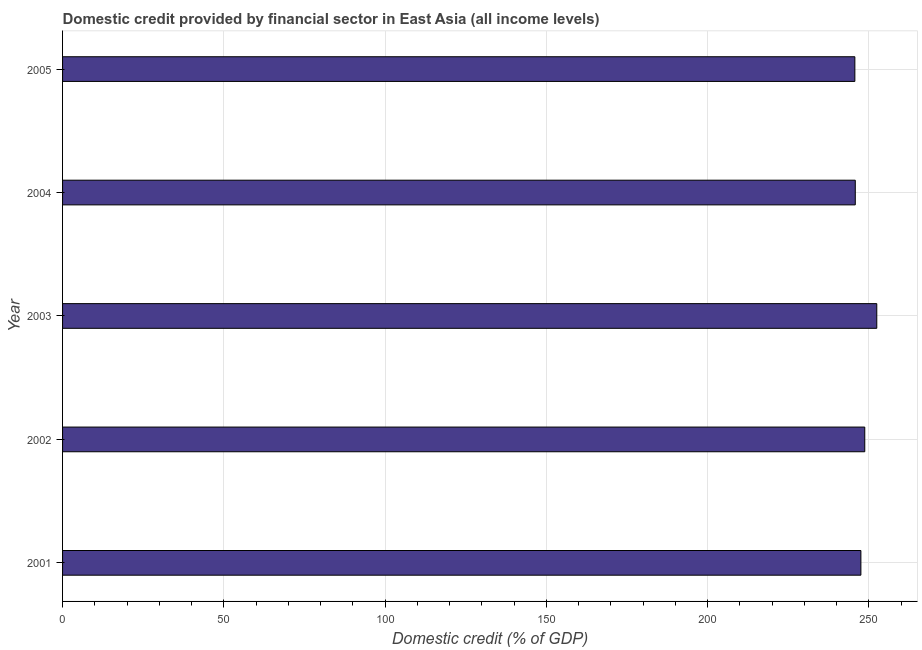What is the title of the graph?
Make the answer very short. Domestic credit provided by financial sector in East Asia (all income levels). What is the label or title of the X-axis?
Your response must be concise. Domestic credit (% of GDP). What is the label or title of the Y-axis?
Offer a very short reply. Year. What is the domestic credit provided by financial sector in 2004?
Ensure brevity in your answer.  245.82. Across all years, what is the maximum domestic credit provided by financial sector?
Offer a terse response. 252.49. Across all years, what is the minimum domestic credit provided by financial sector?
Ensure brevity in your answer.  245.69. In which year was the domestic credit provided by financial sector maximum?
Your answer should be very brief. 2003. In which year was the domestic credit provided by financial sector minimum?
Provide a succinct answer. 2005. What is the sum of the domestic credit provided by financial sector?
Make the answer very short. 1240.33. What is the difference between the domestic credit provided by financial sector in 2004 and 2005?
Make the answer very short. 0.13. What is the average domestic credit provided by financial sector per year?
Provide a succinct answer. 248.07. What is the median domestic credit provided by financial sector?
Give a very brief answer. 247.56. In how many years, is the domestic credit provided by financial sector greater than 110 %?
Offer a terse response. 5. Do a majority of the years between 2001 and 2005 (inclusive) have domestic credit provided by financial sector greater than 240 %?
Offer a very short reply. Yes. What is the ratio of the domestic credit provided by financial sector in 2001 to that in 2002?
Your answer should be very brief. 0.99. What is the difference between the highest and the second highest domestic credit provided by financial sector?
Ensure brevity in your answer.  3.73. Are all the bars in the graph horizontal?
Your answer should be very brief. Yes. What is the difference between two consecutive major ticks on the X-axis?
Give a very brief answer. 50. Are the values on the major ticks of X-axis written in scientific E-notation?
Provide a succinct answer. No. What is the Domestic credit (% of GDP) of 2001?
Offer a terse response. 247.56. What is the Domestic credit (% of GDP) of 2002?
Give a very brief answer. 248.76. What is the Domestic credit (% of GDP) of 2003?
Your response must be concise. 252.49. What is the Domestic credit (% of GDP) in 2004?
Give a very brief answer. 245.82. What is the Domestic credit (% of GDP) of 2005?
Provide a succinct answer. 245.69. What is the difference between the Domestic credit (% of GDP) in 2001 and 2002?
Ensure brevity in your answer.  -1.21. What is the difference between the Domestic credit (% of GDP) in 2001 and 2003?
Keep it short and to the point. -4.93. What is the difference between the Domestic credit (% of GDP) in 2001 and 2004?
Your answer should be compact. 1.74. What is the difference between the Domestic credit (% of GDP) in 2001 and 2005?
Provide a succinct answer. 1.87. What is the difference between the Domestic credit (% of GDP) in 2002 and 2003?
Provide a succinct answer. -3.72. What is the difference between the Domestic credit (% of GDP) in 2002 and 2004?
Offer a terse response. 2.94. What is the difference between the Domestic credit (% of GDP) in 2002 and 2005?
Your answer should be compact. 3.07. What is the difference between the Domestic credit (% of GDP) in 2003 and 2004?
Your answer should be compact. 6.67. What is the difference between the Domestic credit (% of GDP) in 2003 and 2005?
Keep it short and to the point. 6.8. What is the difference between the Domestic credit (% of GDP) in 2004 and 2005?
Your answer should be very brief. 0.13. What is the ratio of the Domestic credit (% of GDP) in 2001 to that in 2002?
Provide a short and direct response. 0.99. What is the ratio of the Domestic credit (% of GDP) in 2001 to that in 2003?
Offer a terse response. 0.98. What is the ratio of the Domestic credit (% of GDP) in 2002 to that in 2003?
Offer a terse response. 0.98. What is the ratio of the Domestic credit (% of GDP) in 2002 to that in 2005?
Provide a short and direct response. 1.01. What is the ratio of the Domestic credit (% of GDP) in 2003 to that in 2004?
Keep it short and to the point. 1.03. What is the ratio of the Domestic credit (% of GDP) in 2003 to that in 2005?
Provide a short and direct response. 1.03. What is the ratio of the Domestic credit (% of GDP) in 2004 to that in 2005?
Your answer should be very brief. 1. 